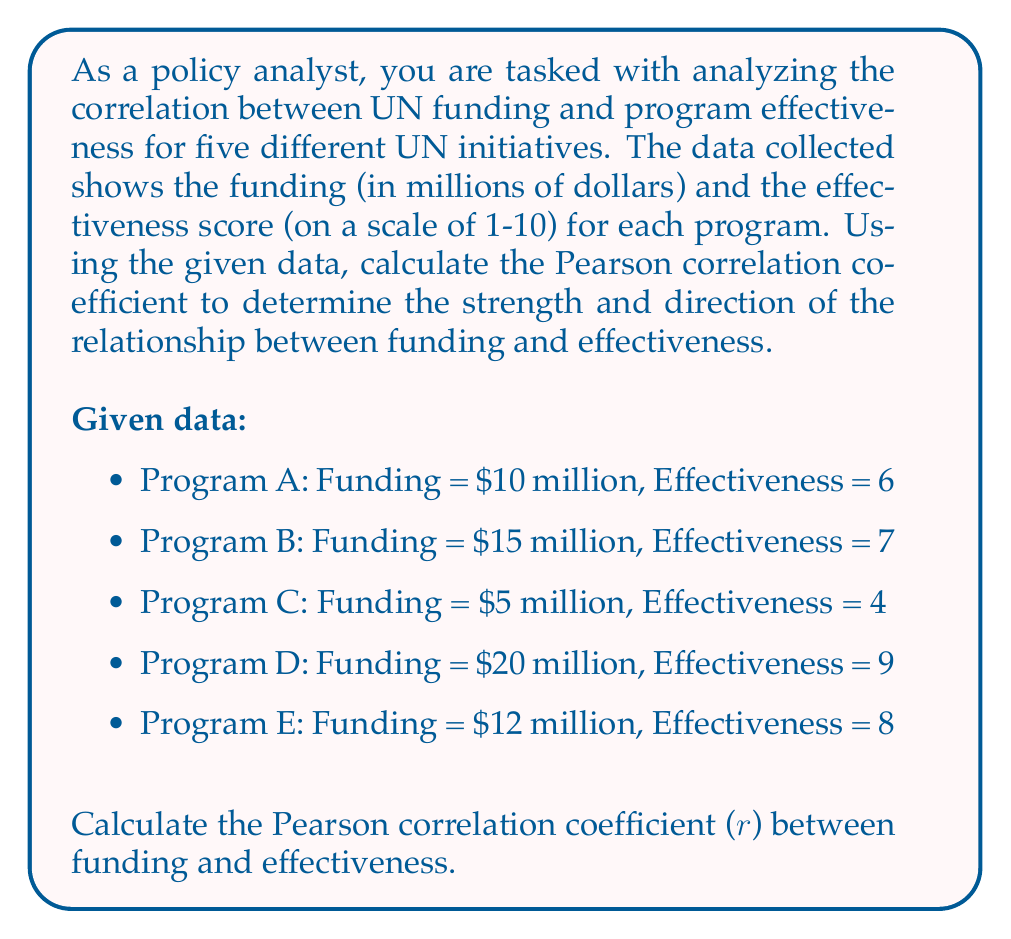Show me your answer to this math problem. To calculate the Pearson correlation coefficient, we'll follow these steps:

1. Calculate the means of funding (X) and effectiveness (Y):
   $\bar{X} = \frac{10 + 15 + 5 + 20 + 12}{5} = 12.4$
   $\bar{Y} = \frac{6 + 7 + 4 + 9 + 8}{5} = 6.8$

2. Calculate the deviations from the mean for both X and Y:
   Program A: $X - \bar{X} = 10 - 12.4 = -2.4$, $Y - \bar{Y} = 6 - 6.8 = -0.8$
   Program B: $X - \bar{X} = 15 - 12.4 = 2.6$, $Y - \bar{Y} = 7 - 6.8 = 0.2$
   Program C: $X - \bar{X} = 5 - 12.4 = -7.4$, $Y - \bar{Y} = 4 - 6.8 = -2.8$
   Program D: $X - \bar{X} = 20 - 12.4 = 7.6$, $Y - \bar{Y} = 9 - 6.8 = 2.2$
   Program E: $X - \bar{X} = 12 - 12.4 = -0.4$, $Y - \bar{Y} = 8 - 6.8 = 1.2$

3. Calculate the products of the deviations and their sum:
   $\sum(X - \bar{X})(Y - \bar{Y}) = (-2.4)(-0.8) + (2.6)(0.2) + (-7.4)(-2.8) + (7.6)(2.2) + (-0.4)(1.2) = 1.92 + 0.52 + 20.72 + 16.72 - 0.48 = 39.4$

4. Calculate the squared deviations and their sums:
   $\sum(X - \bar{X})^2 = (-2.4)^2 + (2.6)^2 + (-7.4)^2 + (7.6)^2 + (-0.4)^2 = 5.76 + 6.76 + 54.76 + 57.76 + 0.16 = 125.2$
   $\sum(Y - \bar{Y})^2 = (-0.8)^2 + (0.2)^2 + (-2.8)^2 + (2.2)^2 + (1.2)^2 = 0.64 + 0.04 + 7.84 + 4.84 + 1.44 = 14.8$

5. Apply the Pearson correlation coefficient formula:
   $$r = \frac{\sum(X - \bar{X})(Y - \bar{Y})}{\sqrt{\sum(X - \bar{X})^2 \sum(Y - \bar{Y})^2}}$$

   $$r = \frac{39.4}{\sqrt{125.2 \times 14.8}} = \frac{39.4}{43.06} \approx 0.915$$
Answer: The Pearson correlation coefficient between UN funding and program effectiveness is approximately 0.915, indicating a strong positive correlation between funding and effectiveness for these UN programs. 